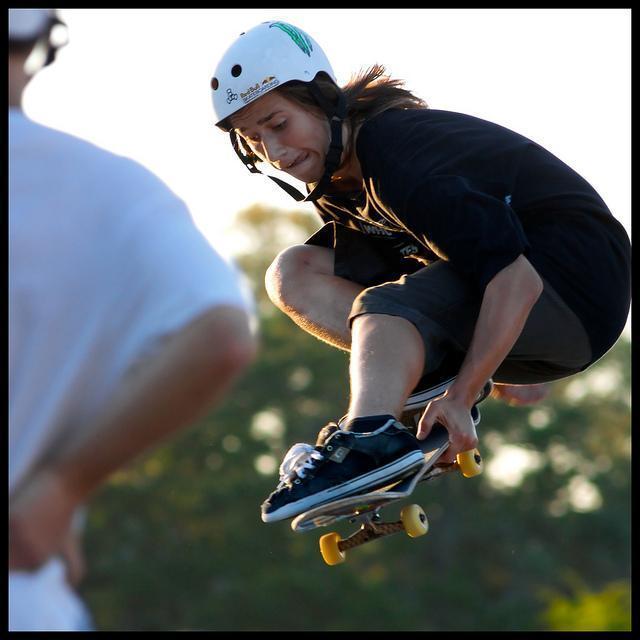How many photos are present?
Give a very brief answer. 1. How many people are in the photo?
Give a very brief answer. 2. 